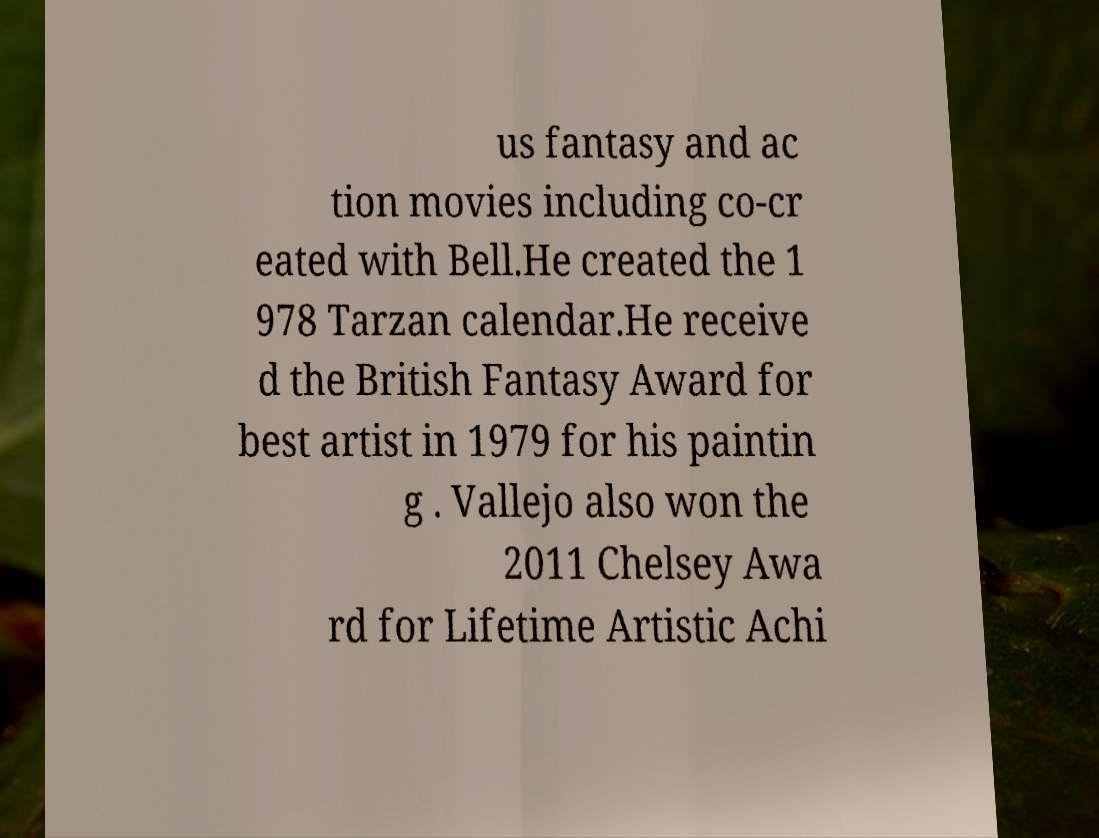Please read and relay the text visible in this image. What does it say? us fantasy and ac tion movies including co-cr eated with Bell.He created the 1 978 Tarzan calendar.He receive d the British Fantasy Award for best artist in 1979 for his paintin g . Vallejo also won the 2011 Chelsey Awa rd for Lifetime Artistic Achi 